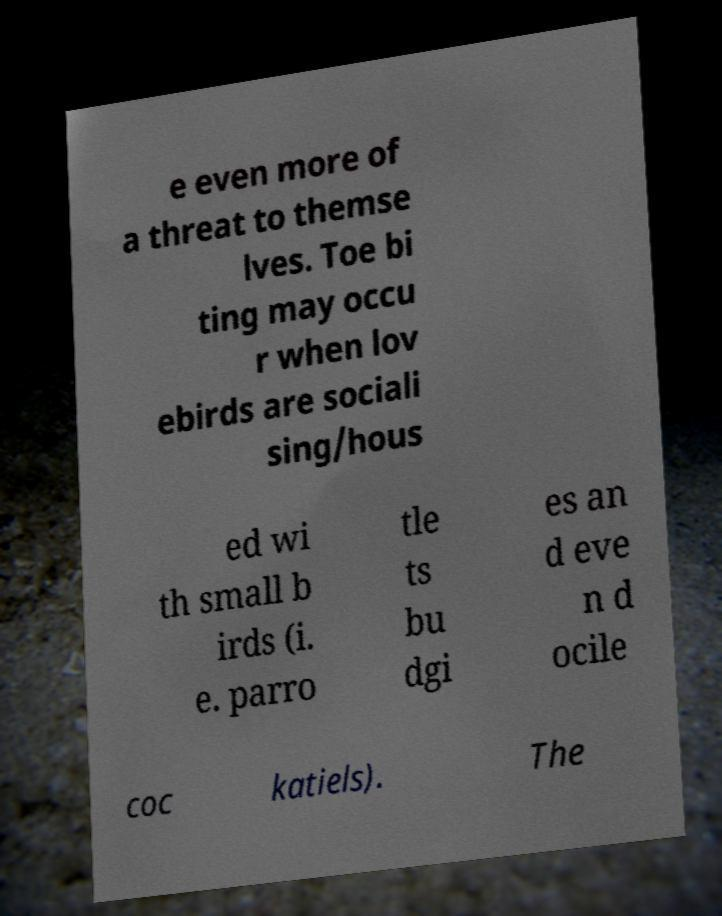I need the written content from this picture converted into text. Can you do that? e even more of a threat to themse lves. Toe bi ting may occu r when lov ebirds are sociali sing/hous ed wi th small b irds (i. e. parro tle ts bu dgi es an d eve n d ocile coc katiels). The 